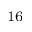<formula> <loc_0><loc_0><loc_500><loc_500>^ { 1 6 }</formula> 